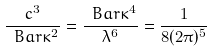<formula> <loc_0><loc_0><loc_500><loc_500>\frac { c ^ { 3 } } { \ B a r { \kappa } ^ { 2 } } = \frac { \ B a r { \kappa } ^ { 4 } } { \lambda ^ { 6 } } = \frac { 1 } { 8 ( 2 \pi ) ^ { 5 } }</formula> 